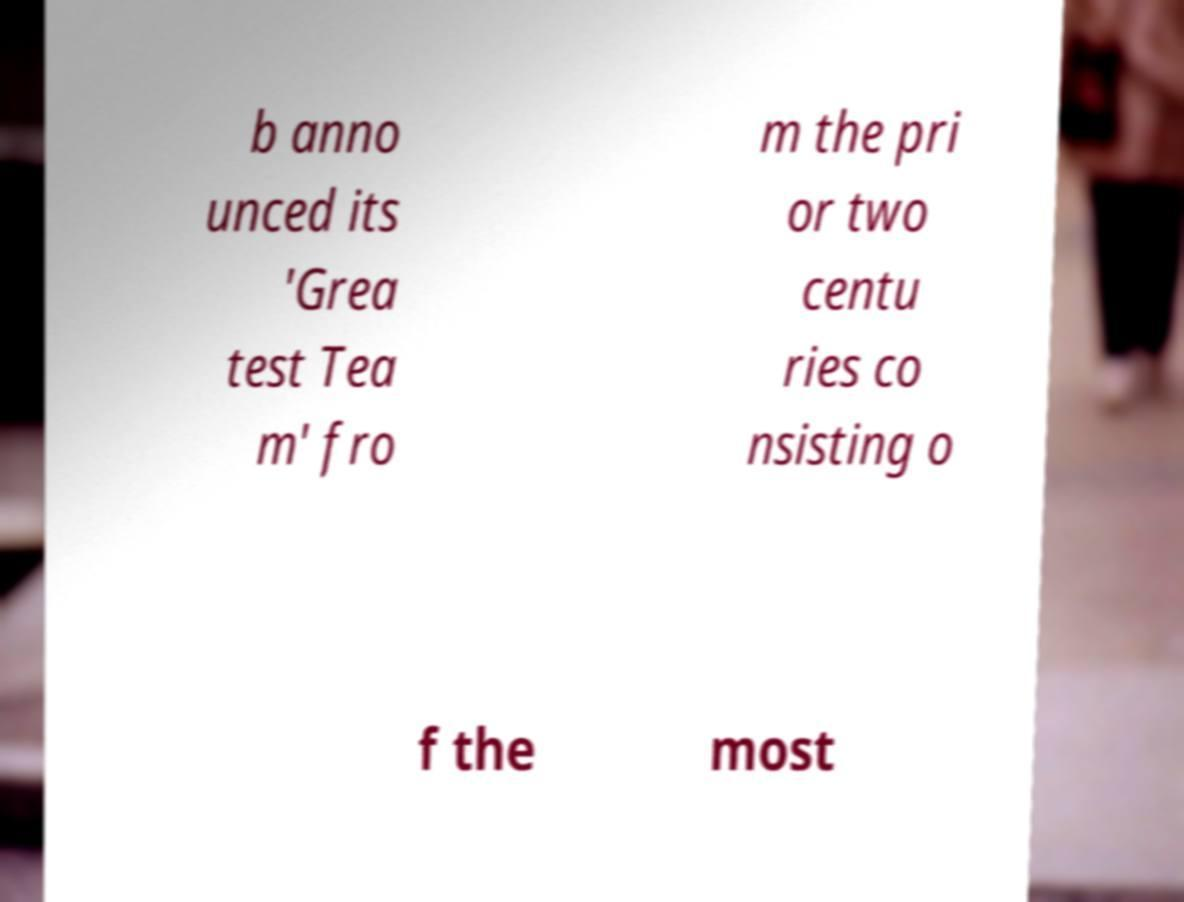Could you assist in decoding the text presented in this image and type it out clearly? b anno unced its 'Grea test Tea m' fro m the pri or two centu ries co nsisting o f the most 